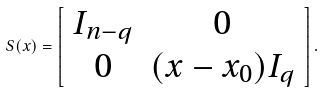Convert formula to latex. <formula><loc_0><loc_0><loc_500><loc_500>S ( x ) = \left [ \begin{array} { c c } I _ { n - q } & 0 \\ 0 & ( x - x _ { 0 } ) I _ { q } \\ \end{array} \right ] .</formula> 